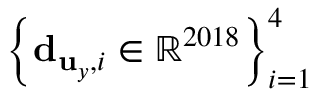Convert formula to latex. <formula><loc_0><loc_0><loc_500><loc_500>\left \{ { d } _ { { u } _ { y } , i } \in \mathbb { R } ^ { 2 0 1 8 } \right \} _ { i = 1 } ^ { 4 }</formula> 